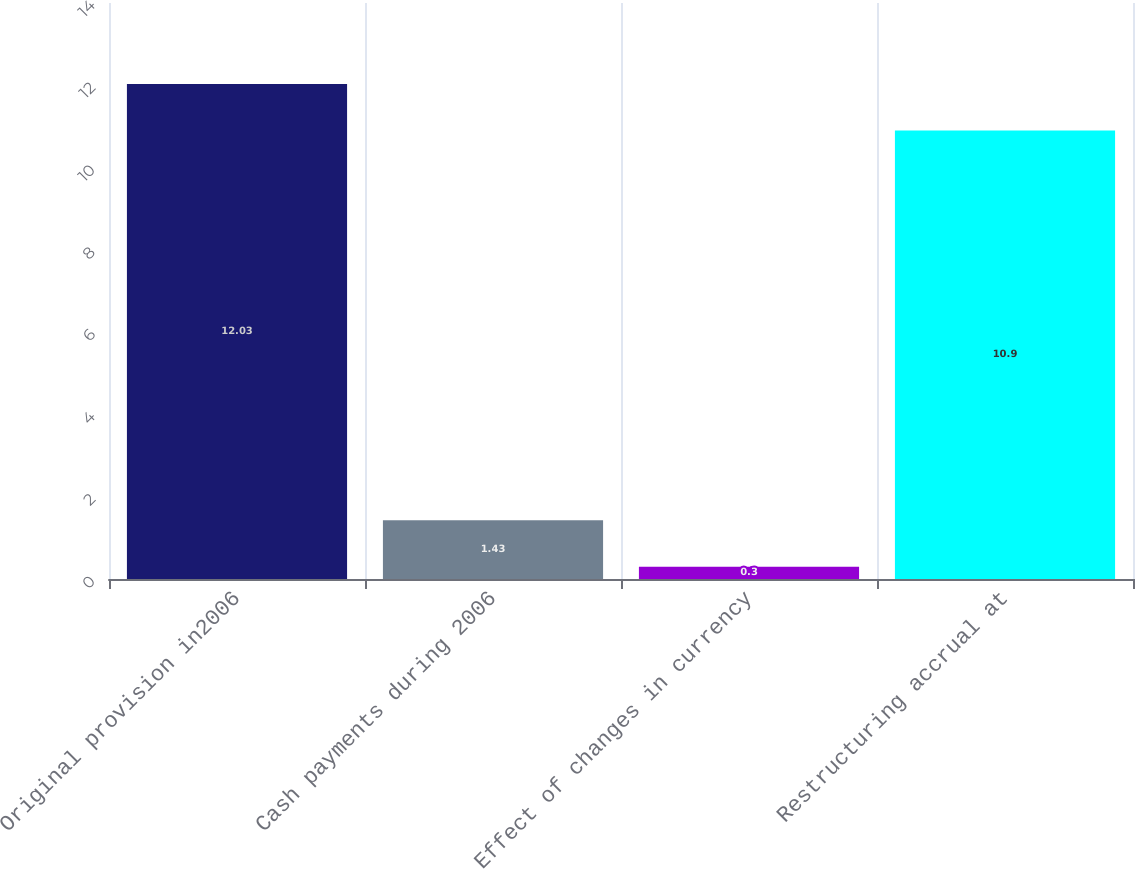Convert chart. <chart><loc_0><loc_0><loc_500><loc_500><bar_chart><fcel>Original provision in2006<fcel>Cash payments during 2006<fcel>Effect of changes in currency<fcel>Restructuring accrual at<nl><fcel>12.03<fcel>1.43<fcel>0.3<fcel>10.9<nl></chart> 